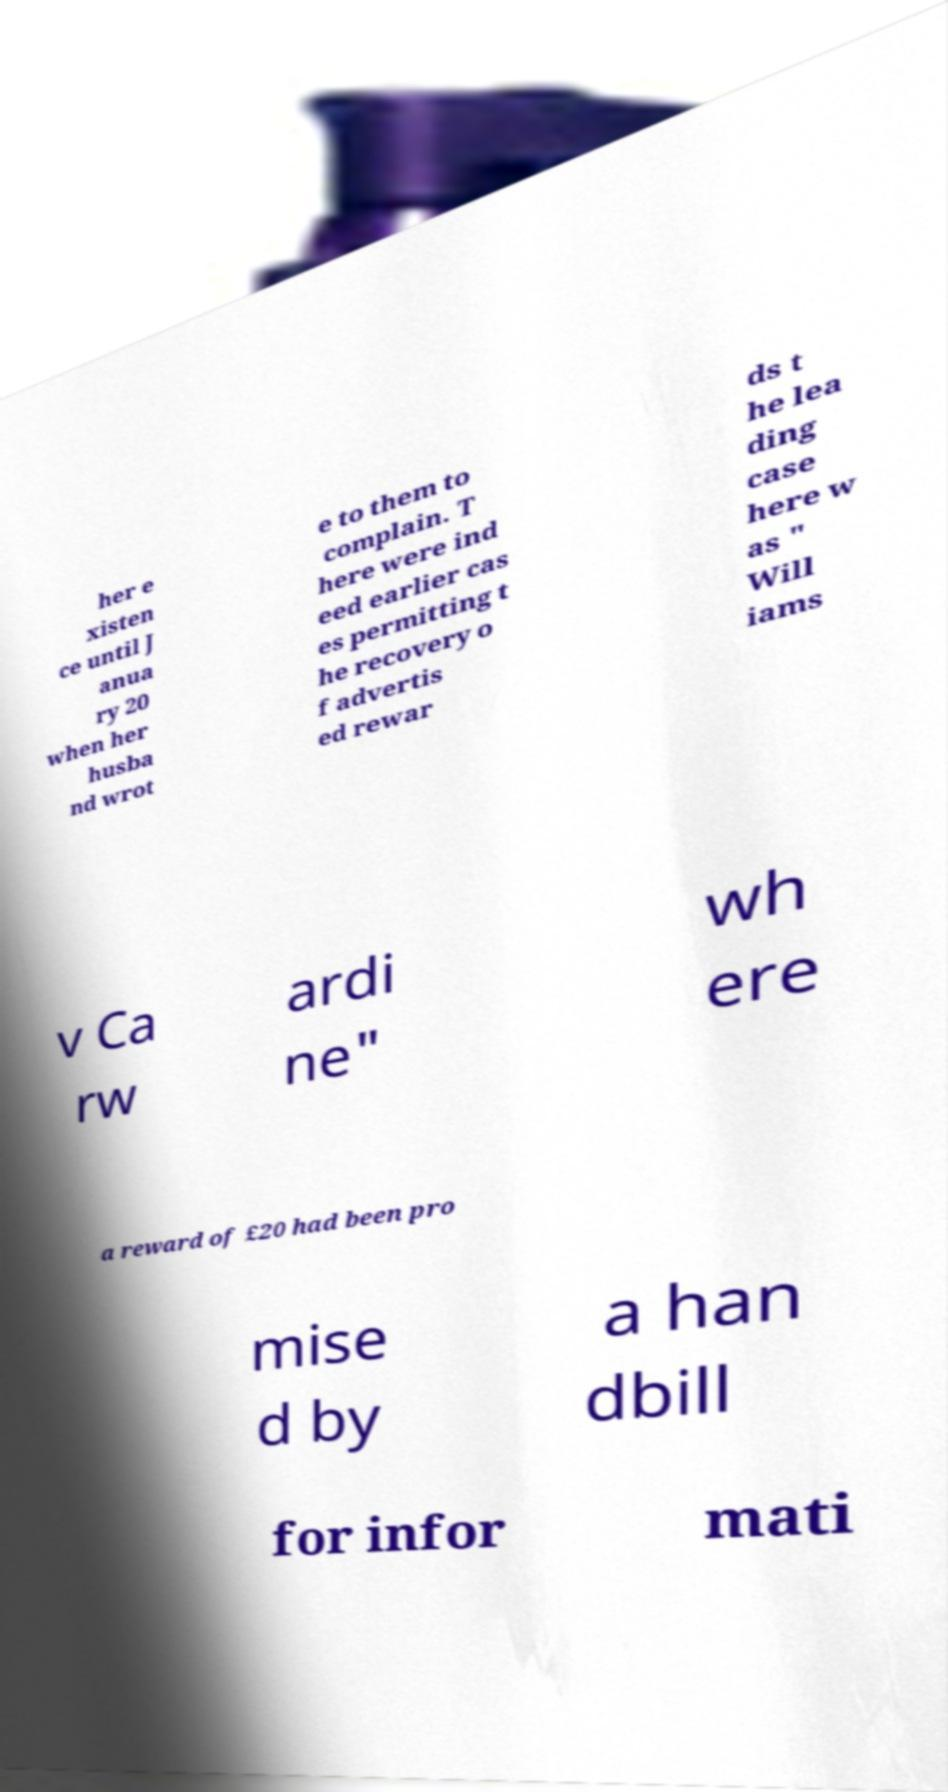Please read and relay the text visible in this image. What does it say? her e xisten ce until J anua ry 20 when her husba nd wrot e to them to complain. T here were ind eed earlier cas es permitting t he recovery o f advertis ed rewar ds t he lea ding case here w as " Will iams v Ca rw ardi ne" wh ere a reward of £20 had been pro mise d by a han dbill for infor mati 